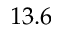Convert formula to latex. <formula><loc_0><loc_0><loc_500><loc_500>1 3 . 6</formula> 